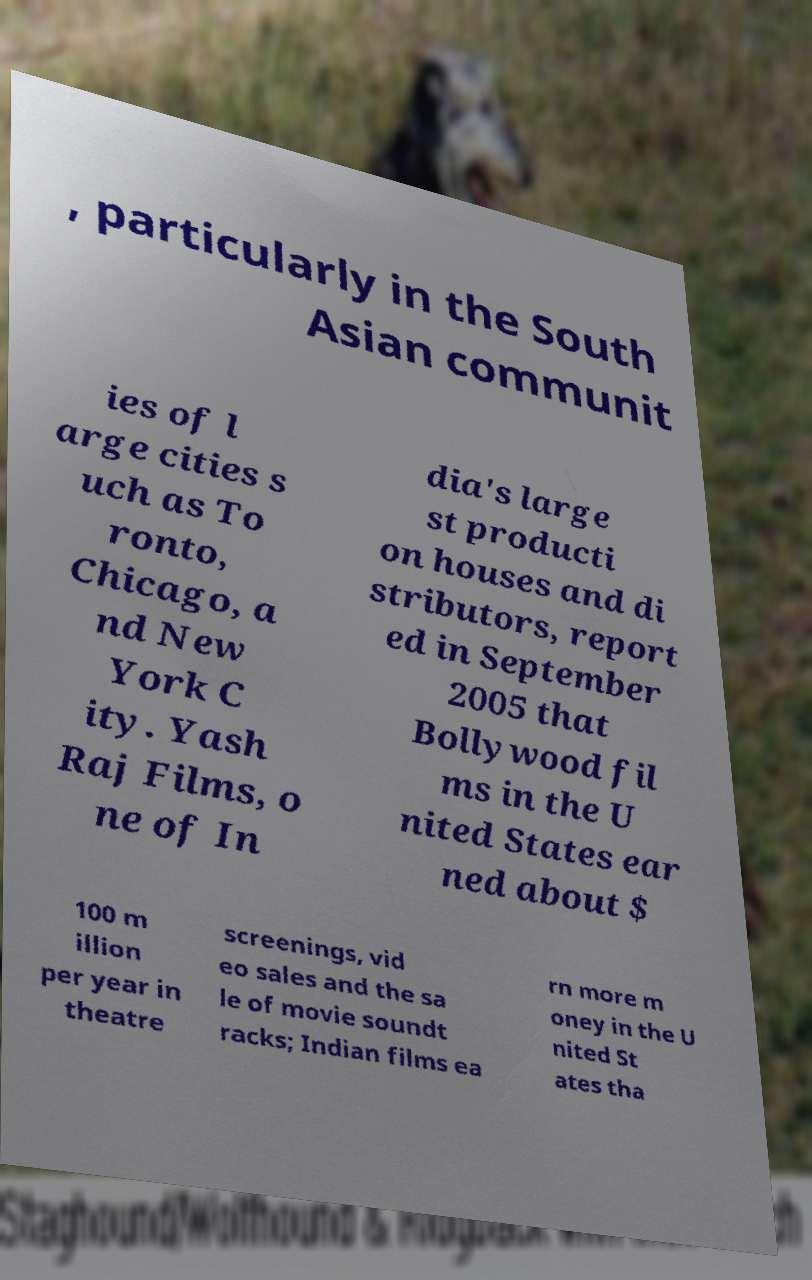There's text embedded in this image that I need extracted. Can you transcribe it verbatim? , particularly in the South Asian communit ies of l arge cities s uch as To ronto, Chicago, a nd New York C ity. Yash Raj Films, o ne of In dia's large st producti on houses and di stributors, report ed in September 2005 that Bollywood fil ms in the U nited States ear ned about $ 100 m illion per year in theatre screenings, vid eo sales and the sa le of movie soundt racks; Indian films ea rn more m oney in the U nited St ates tha 